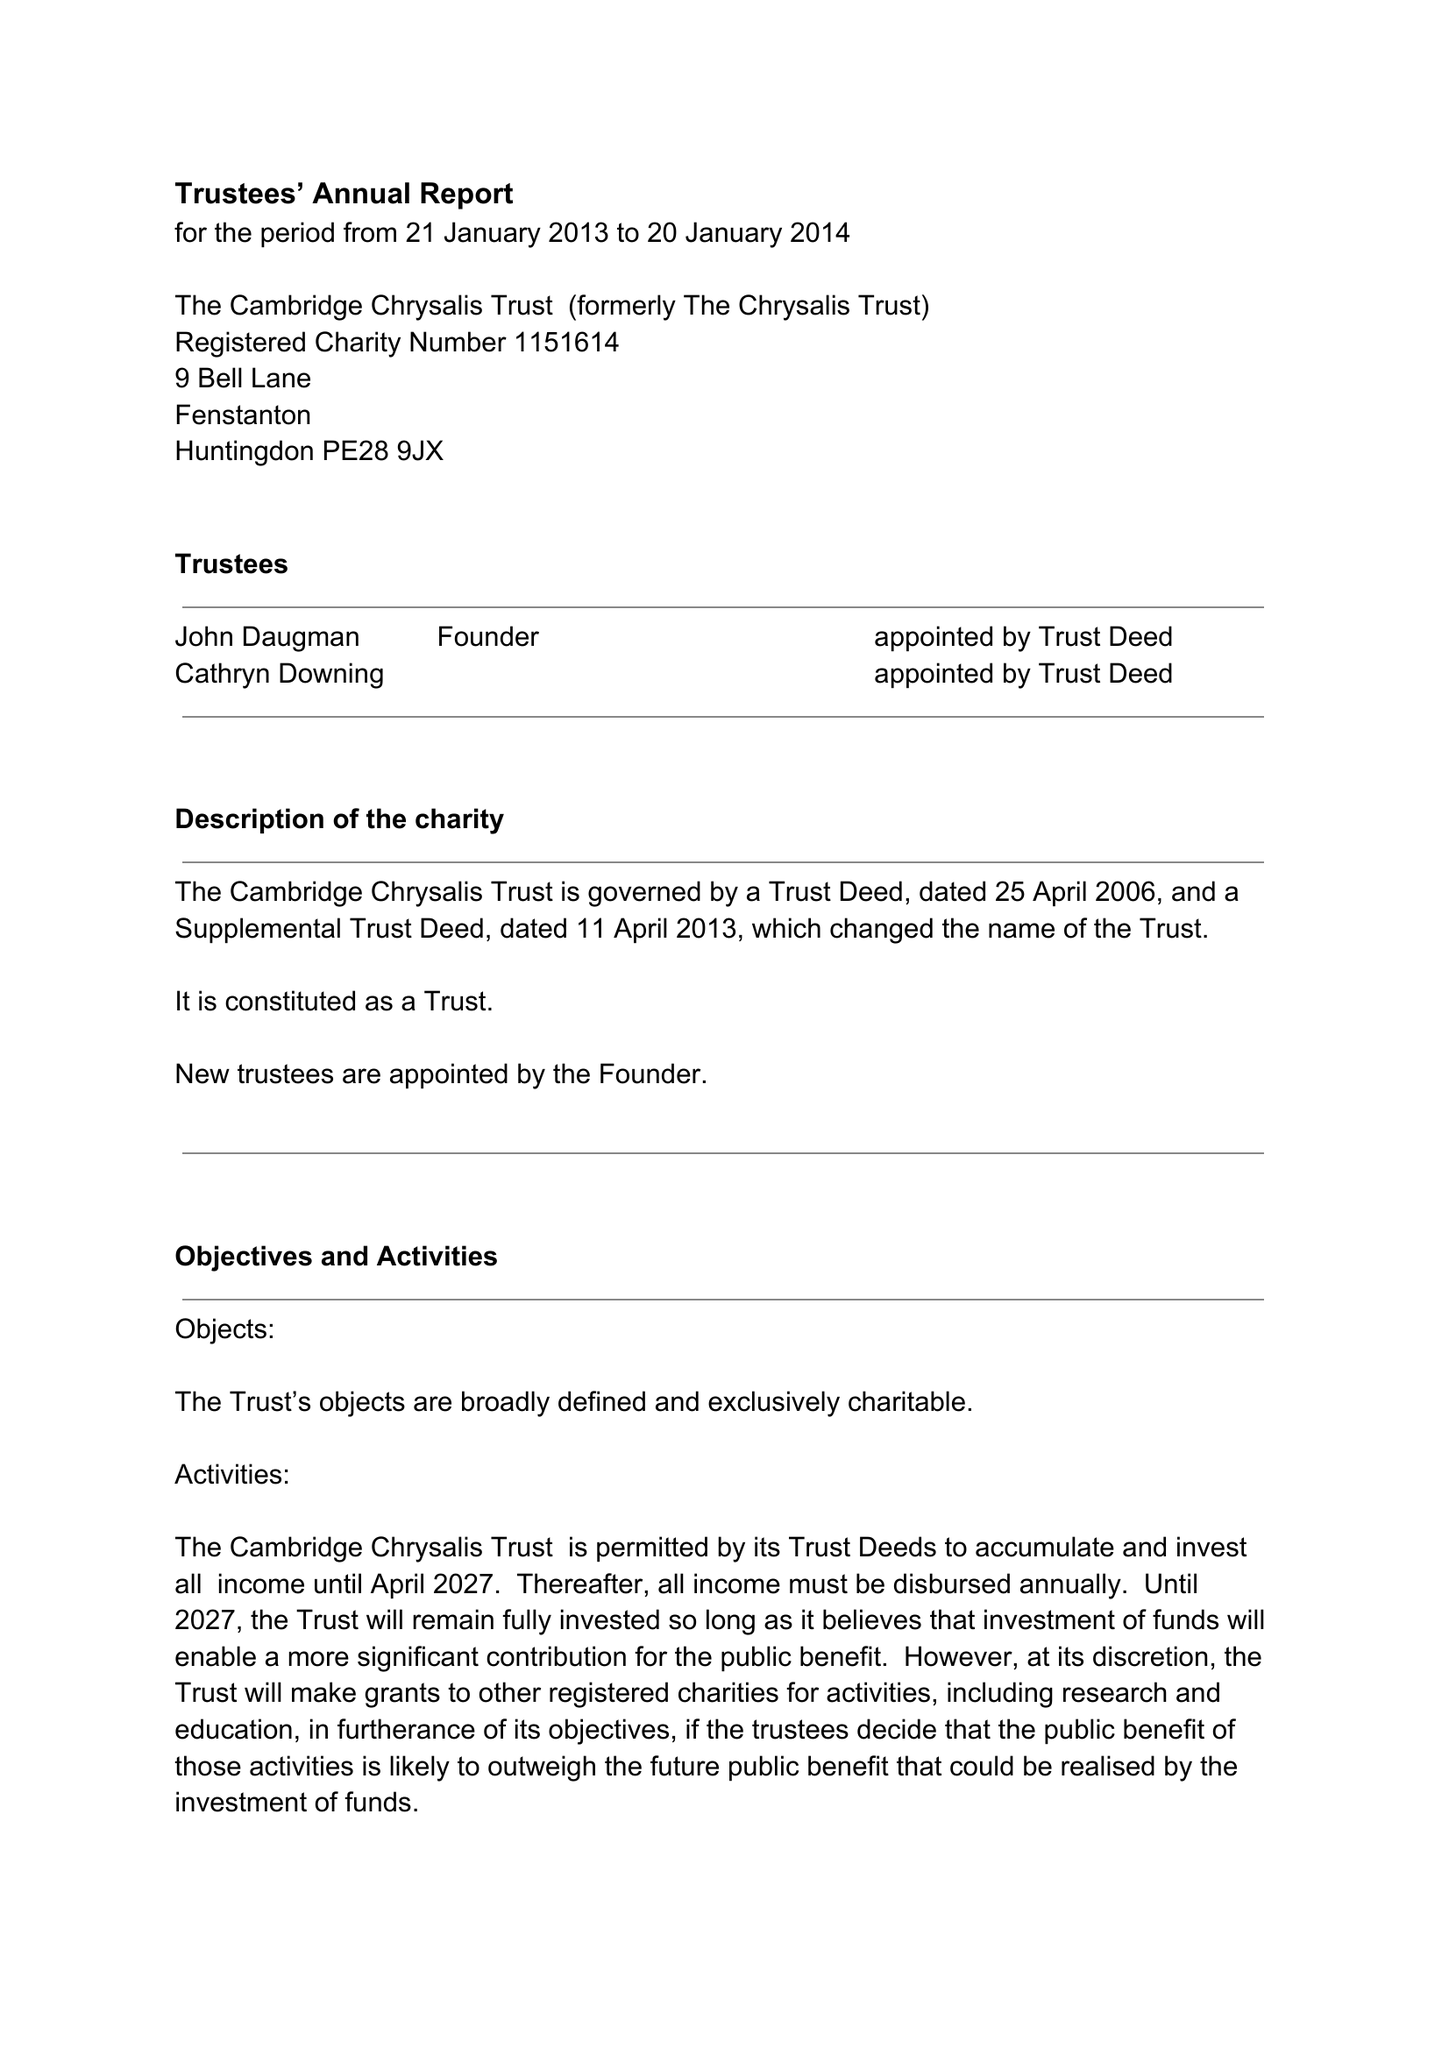What is the value for the report_date?
Answer the question using a single word or phrase. 2014-01-20 